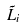<formula> <loc_0><loc_0><loc_500><loc_500>\tilde { L } _ { i }</formula> 